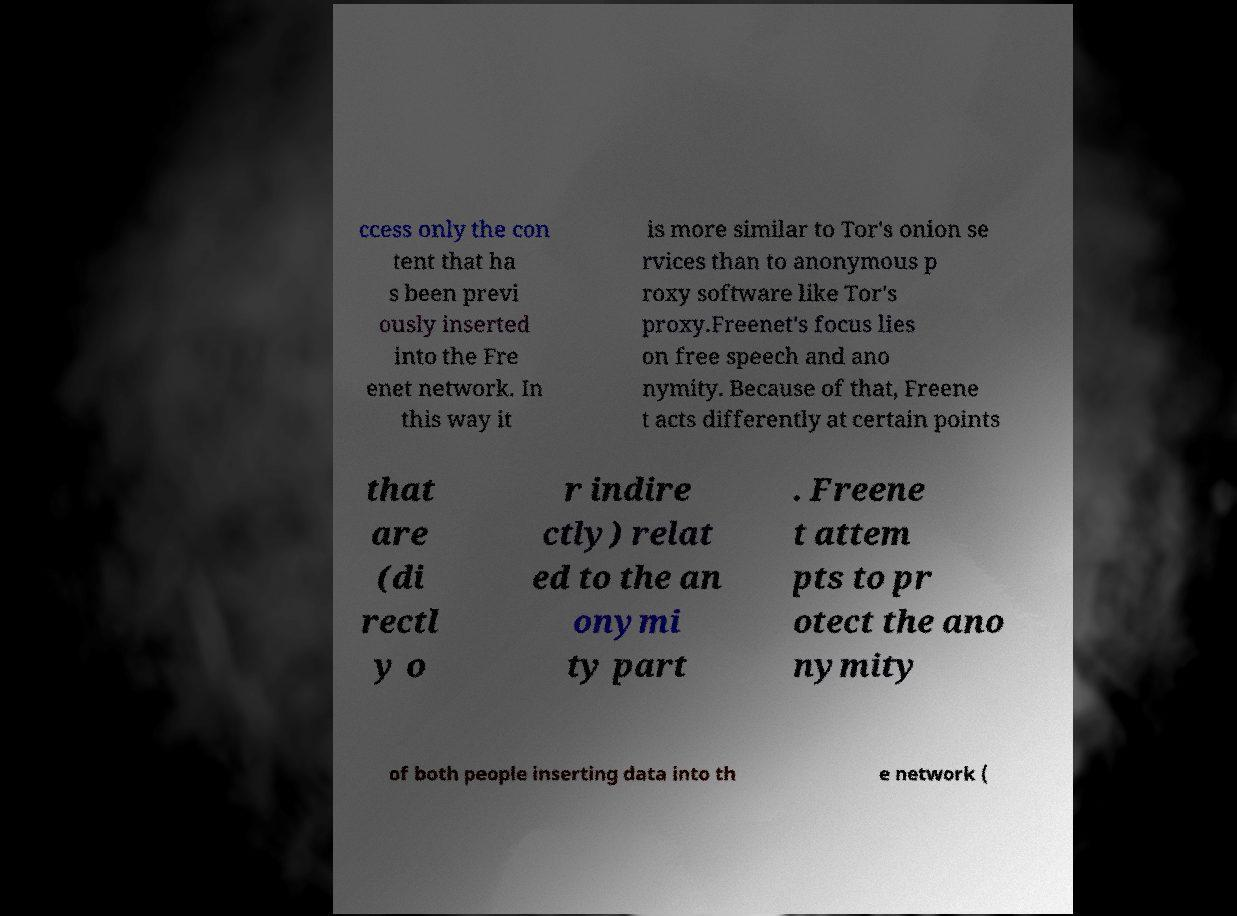I need the written content from this picture converted into text. Can you do that? ccess only the con tent that ha s been previ ously inserted into the Fre enet network. In this way it is more similar to Tor's onion se rvices than to anonymous p roxy software like Tor's proxy.Freenet's focus lies on free speech and ano nymity. Because of that, Freene t acts differently at certain points that are (di rectl y o r indire ctly) relat ed to the an onymi ty part . Freene t attem pts to pr otect the ano nymity of both people inserting data into th e network ( 